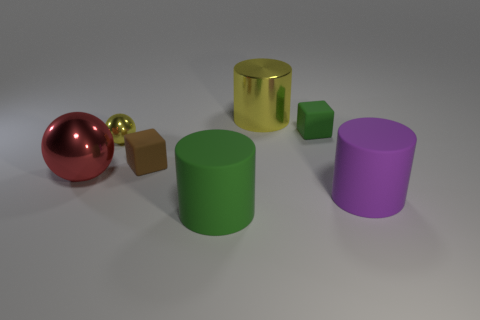What material is the purple thing that is the same shape as the big green object?
Your answer should be very brief. Rubber. What material is the small thing that is on the right side of the big cylinder in front of the purple cylinder that is to the right of the large red object?
Offer a terse response. Rubber. Are there fewer tiny blue rubber balls than red metal things?
Ensure brevity in your answer.  Yes. Are the small sphere and the big purple cylinder made of the same material?
Give a very brief answer. No. What is the shape of the other metal thing that is the same color as the small metallic thing?
Offer a terse response. Cylinder. Is the color of the block behind the yellow sphere the same as the tiny shiny sphere?
Provide a short and direct response. No. There is a green rubber thing that is in front of the big purple cylinder; what number of green objects are in front of it?
Provide a succinct answer. 0. There is a metal cylinder that is the same size as the red metal thing; what is its color?
Make the answer very short. Yellow. What is the material of the green thing in front of the red metallic thing?
Your answer should be compact. Rubber. There is a small object that is both behind the brown rubber object and on the right side of the small sphere; what is its material?
Make the answer very short. Rubber. 